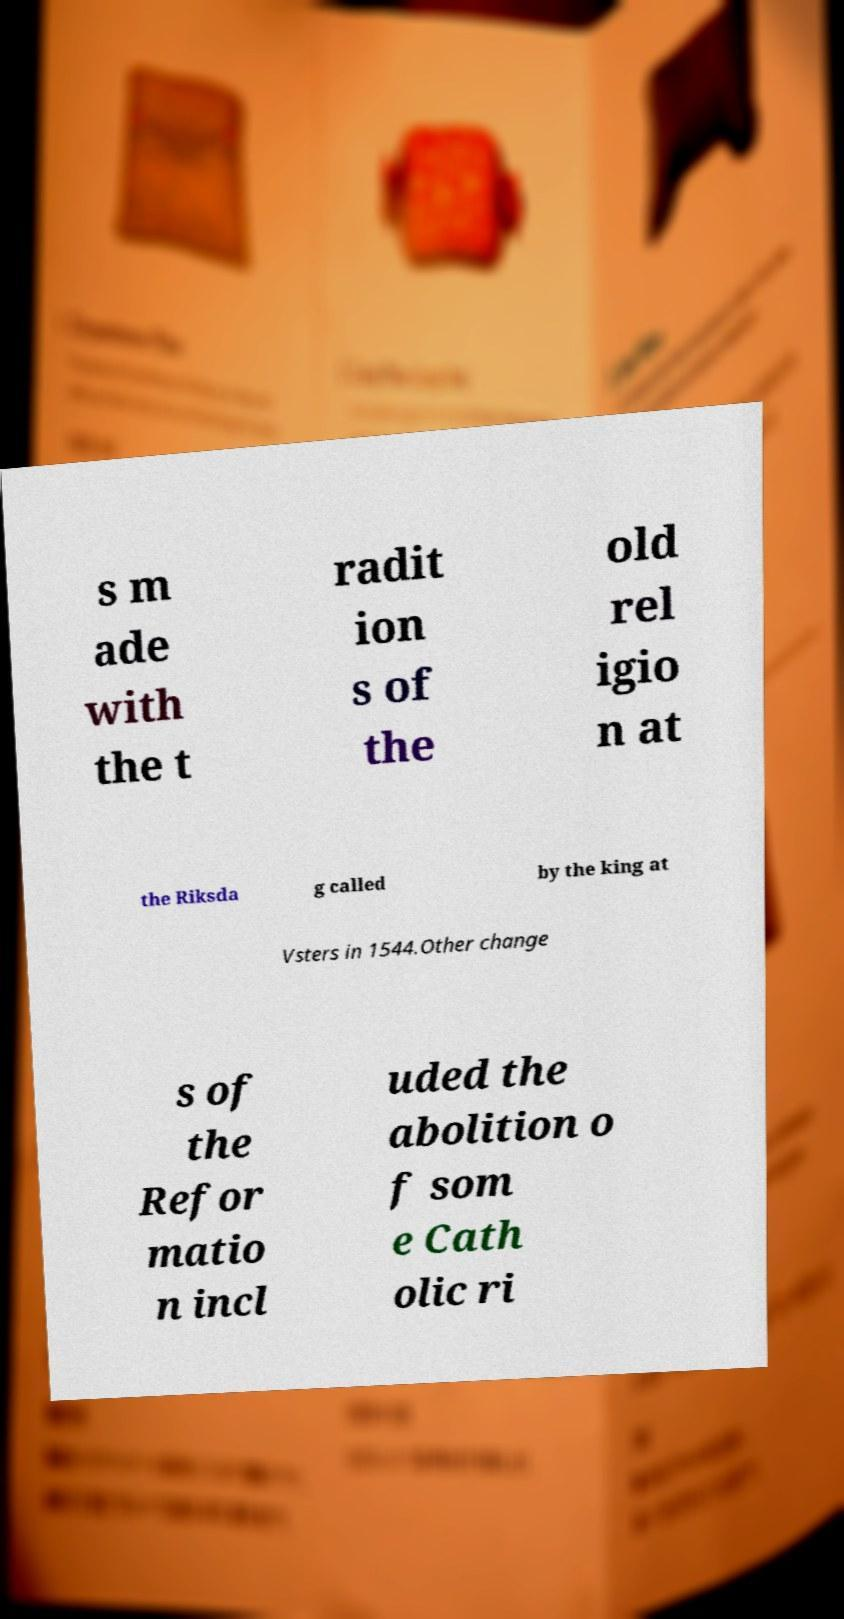There's text embedded in this image that I need extracted. Can you transcribe it verbatim? s m ade with the t radit ion s of the old rel igio n at the Riksda g called by the king at Vsters in 1544.Other change s of the Refor matio n incl uded the abolition o f som e Cath olic ri 